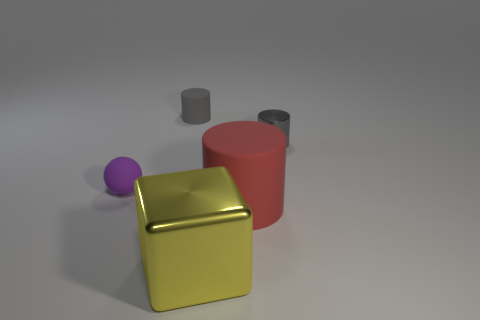Add 4 big shiny things. How many objects exist? 9 Subtract all cubes. How many objects are left? 4 Subtract all big metallic blocks. Subtract all large brown rubber blocks. How many objects are left? 4 Add 4 tiny balls. How many tiny balls are left? 5 Add 5 blue rubber blocks. How many blue rubber blocks exist? 5 Subtract 0 brown balls. How many objects are left? 5 